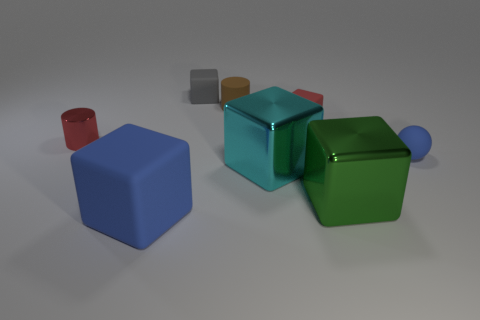Is the number of big cyan objects greater than the number of large cyan cylinders?
Provide a succinct answer. Yes. Are there more red objects to the right of the matte cylinder than big rubber cubes that are on the right side of the big green cube?
Offer a terse response. Yes. What is the size of the block that is behind the tiny red metallic cylinder and to the right of the rubber cylinder?
Provide a short and direct response. Small. What number of red things are the same size as the red metal cylinder?
Keep it short and to the point. 1. Does the small thing that is on the left side of the big blue rubber cube have the same shape as the brown matte thing?
Make the answer very short. Yes. Is the number of small gray matte blocks that are behind the ball less than the number of blue objects?
Offer a very short reply. Yes. Are there any large cubes that have the same color as the tiny rubber ball?
Offer a terse response. Yes. There is a red metal object; does it have the same shape as the brown thing that is right of the red metal cylinder?
Offer a very short reply. Yes. Is there a thing made of the same material as the cyan cube?
Your response must be concise. Yes. There is a blue matte ball that is behind the metallic cube that is left of the green shiny block; is there a large rubber thing that is in front of it?
Your answer should be compact. Yes. 